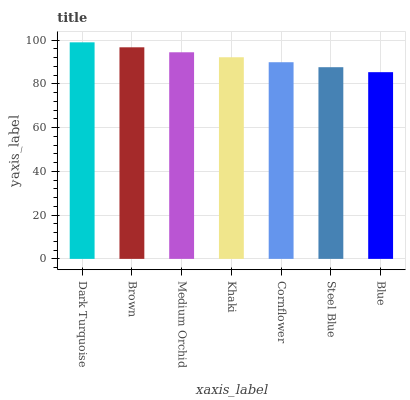Is Brown the minimum?
Answer yes or no. No. Is Brown the maximum?
Answer yes or no. No. Is Dark Turquoise greater than Brown?
Answer yes or no. Yes. Is Brown less than Dark Turquoise?
Answer yes or no. Yes. Is Brown greater than Dark Turquoise?
Answer yes or no. No. Is Dark Turquoise less than Brown?
Answer yes or no. No. Is Khaki the high median?
Answer yes or no. Yes. Is Khaki the low median?
Answer yes or no. Yes. Is Medium Orchid the high median?
Answer yes or no. No. Is Medium Orchid the low median?
Answer yes or no. No. 